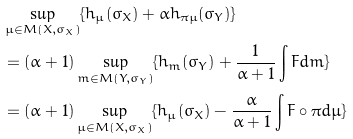Convert formula to latex. <formula><loc_0><loc_0><loc_500><loc_500>& \sup _ { \mu \in M ( X , \sigma _ { X } ) } \{ h _ { \mu } ( \sigma _ { X } ) + \alpha h _ { \pi \mu } ( \sigma _ { Y } ) \} \\ & = ( \alpha + 1 ) \sup _ { m \in M ( Y , \sigma _ { Y } ) } \{ h _ { m } ( \sigma _ { Y } ) + \frac { 1 } { \alpha + 1 } \int F d m \} \\ & = ( \alpha + 1 ) \sup _ { \mu \in M ( X , \sigma _ { X } ) } \{ h _ { \mu } ( \sigma _ { X } ) - \frac { \alpha } { \alpha + 1 } \int F \circ \pi d \mu \}</formula> 